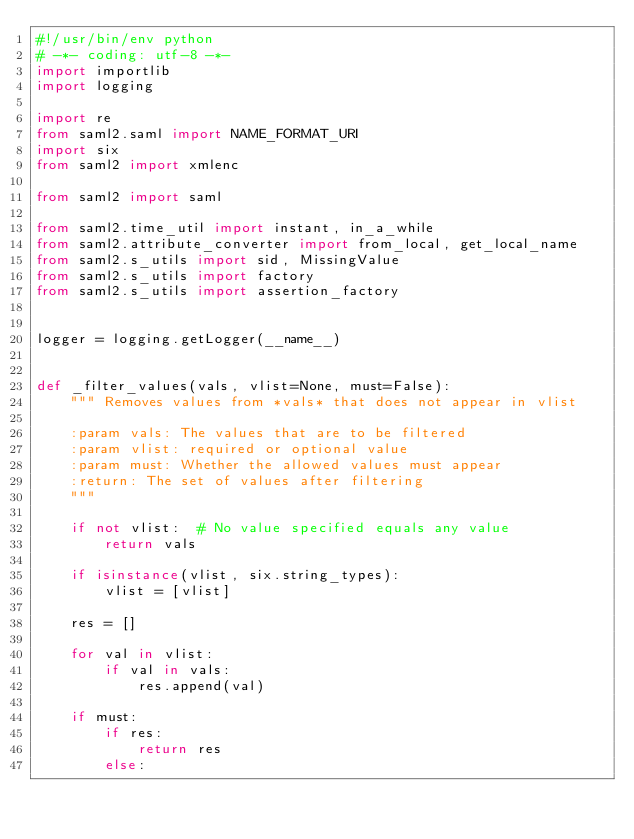Convert code to text. <code><loc_0><loc_0><loc_500><loc_500><_Python_>#!/usr/bin/env python
# -*- coding: utf-8 -*-
import importlib
import logging

import re
from saml2.saml import NAME_FORMAT_URI
import six
from saml2 import xmlenc

from saml2 import saml

from saml2.time_util import instant, in_a_while
from saml2.attribute_converter import from_local, get_local_name
from saml2.s_utils import sid, MissingValue
from saml2.s_utils import factory
from saml2.s_utils import assertion_factory


logger = logging.getLogger(__name__)


def _filter_values(vals, vlist=None, must=False):
    """ Removes values from *vals* that does not appear in vlist

    :param vals: The values that are to be filtered
    :param vlist: required or optional value
    :param must: Whether the allowed values must appear
    :return: The set of values after filtering
    """

    if not vlist:  # No value specified equals any value
        return vals

    if isinstance(vlist, six.string_types):
        vlist = [vlist]

    res = []

    for val in vlist:
        if val in vals:
            res.append(val)

    if must:
        if res:
            return res
        else:</code> 